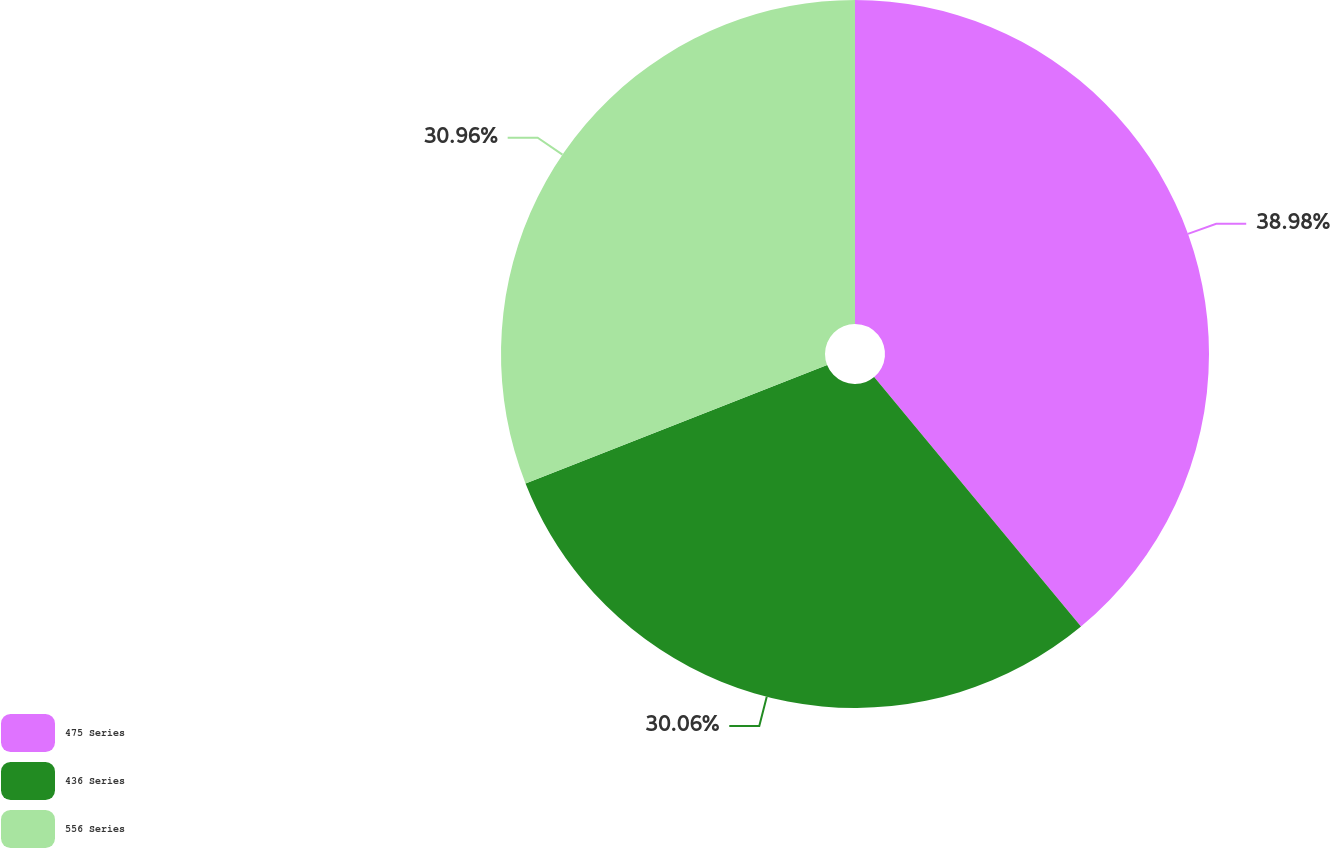Convert chart. <chart><loc_0><loc_0><loc_500><loc_500><pie_chart><fcel>475 Series<fcel>436 Series<fcel>556 Series<nl><fcel>38.98%<fcel>30.06%<fcel>30.96%<nl></chart> 